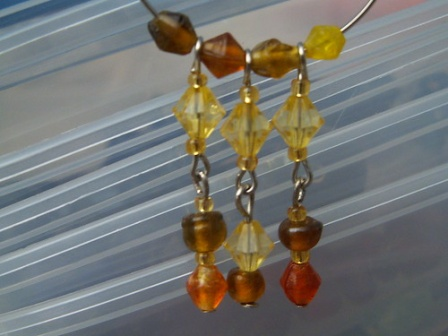Describe the design and materials used in these earrings. The earrings display a delightful design composed of three beads connected by delicate silver chains. The top bead is a small, earthy brown, followed by a larger, faceted yellow bead that adds a bright touch. The bottom bead is smaller and red, completing the colorful trio. These beads are carefully selected to provide a harmonious color contrast. The silver chains not only add elegance but also function as a lightweight and durable connector, ensuring the beads hang freely and catch the light beautifully. 